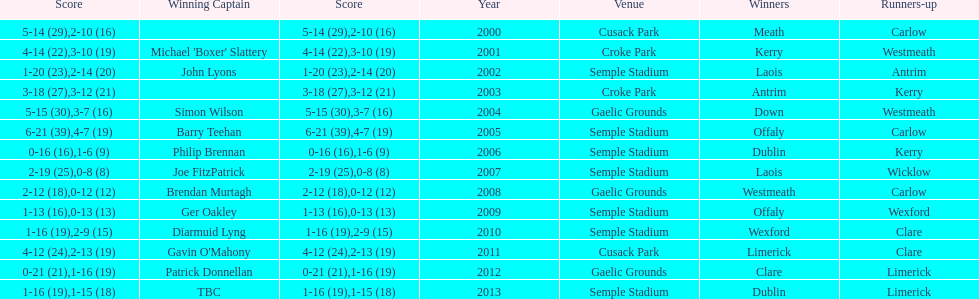Who was the winner after 2007? Laois. 